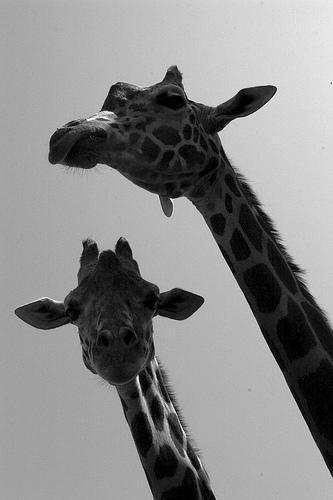How many giraffes are there?
Give a very brief answer. 2. 